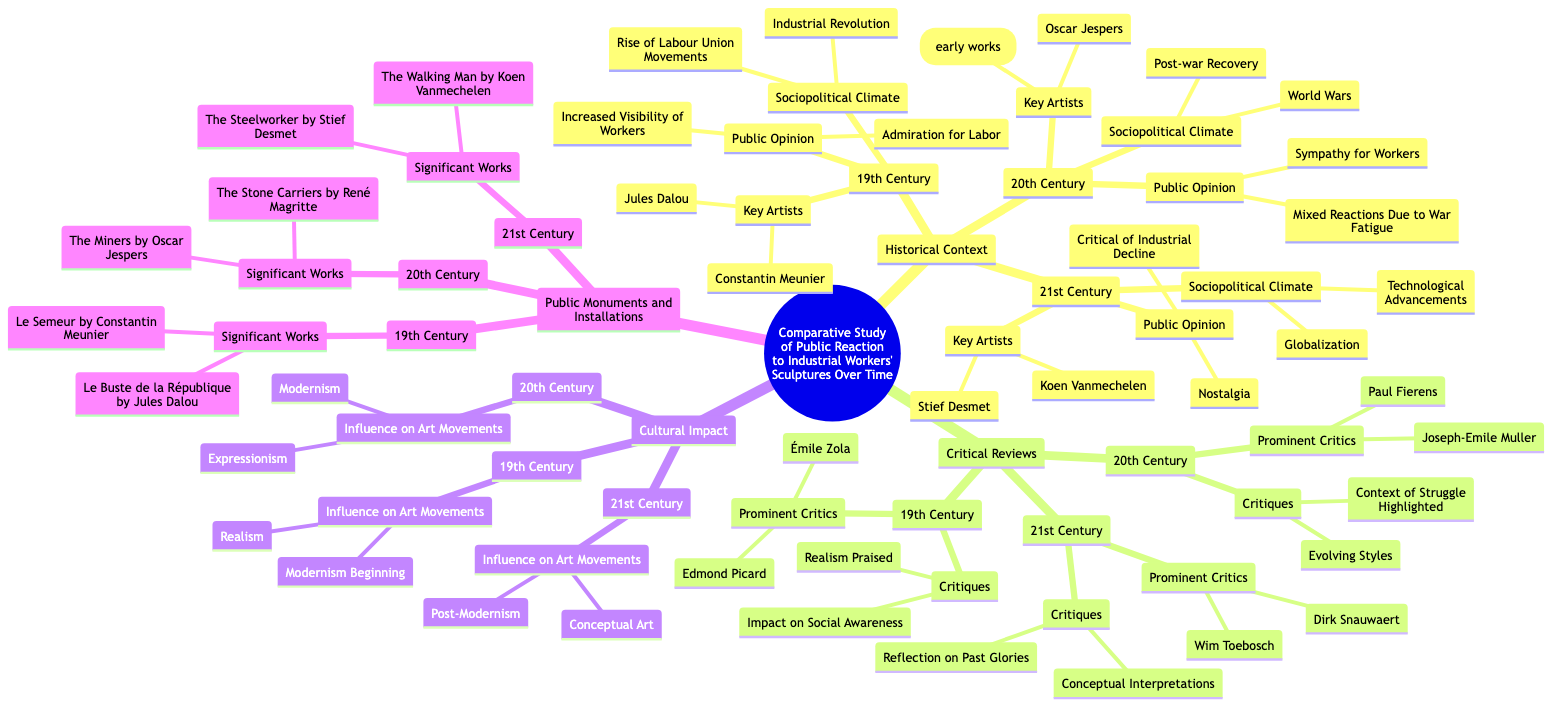What key artists are associated with the 19th Century? The 19th Century section lists the key artists as Constantin Meunier and Jules Dalou. By directly checking this section, we see these names without variations.
Answer: Constantin Meunier, Jules Dalou Which sociopolitical climate is noted for the 20th Century? The 20th Century mentions "World Wars" and "Post-war Recovery" as its sociopolitical climate. Checking this area provides both elements explicitly.
Answer: World Wars, Post-war Recovery How many prominent critics are identified in the 21st Century? In the 21st Century, there are two prominent critics listed: Wim Toebosch and Dirk Snauwaert. Counting the names provides the total of two.
Answer: 2 What is the influence on art movements during the 19th Century? The 19th Century indicates that its influence on art movements includes "Realism" and "Modernism Beginning." Referencing this section leads us to these movements.
Answer: Realism, Modernism Beginning Which public opinion is common in the 21st Century? The 21st Century cites public opinion as "Nostalgia" and "Critical of Industrial Decline." These sentiments point to how society feels about industrial workers.
Answer: Nostalgia, Critical of Industrial Decline What significant work is attributed to Constantin Meunier? Under the 19th Century, "Le Semeur" is highlighted as a significant work by Constantin Meunier. This title is clearly noted in that section.
Answer: Le Semeur What critiques are associated with the 20th Century? The 20th Century includes critiques like "Evolving Styles" and "Context of Struggle Highlighted." By reviewing this part of the diagram, both critiques can be identified.
Answer: Evolving Styles, Context of Struggle Highlighted How does the public opinion shift from the 19th to the 20th Century? Examining the public opinions, we see a transition from "Admiration for Labor" in the 19th Century to "Sympathy for Workers" in the 20th Century, indicating a more empathetic stance over time.
Answer: From Admiration for Labor to Sympathy for Workers What is the key difference in cultural impact between the 19th and 21st Centuries? In the 19th Century, the influence is on "Realism" and "Modernism Beginning," while the 21st Century shows influences of "Post-Modernism" and "Conceptual Art." This comparison reveals a shift in artistic philosophy.
Answer: Shift from Realism/Modernism to Post-Modernism/Conceptual Art 